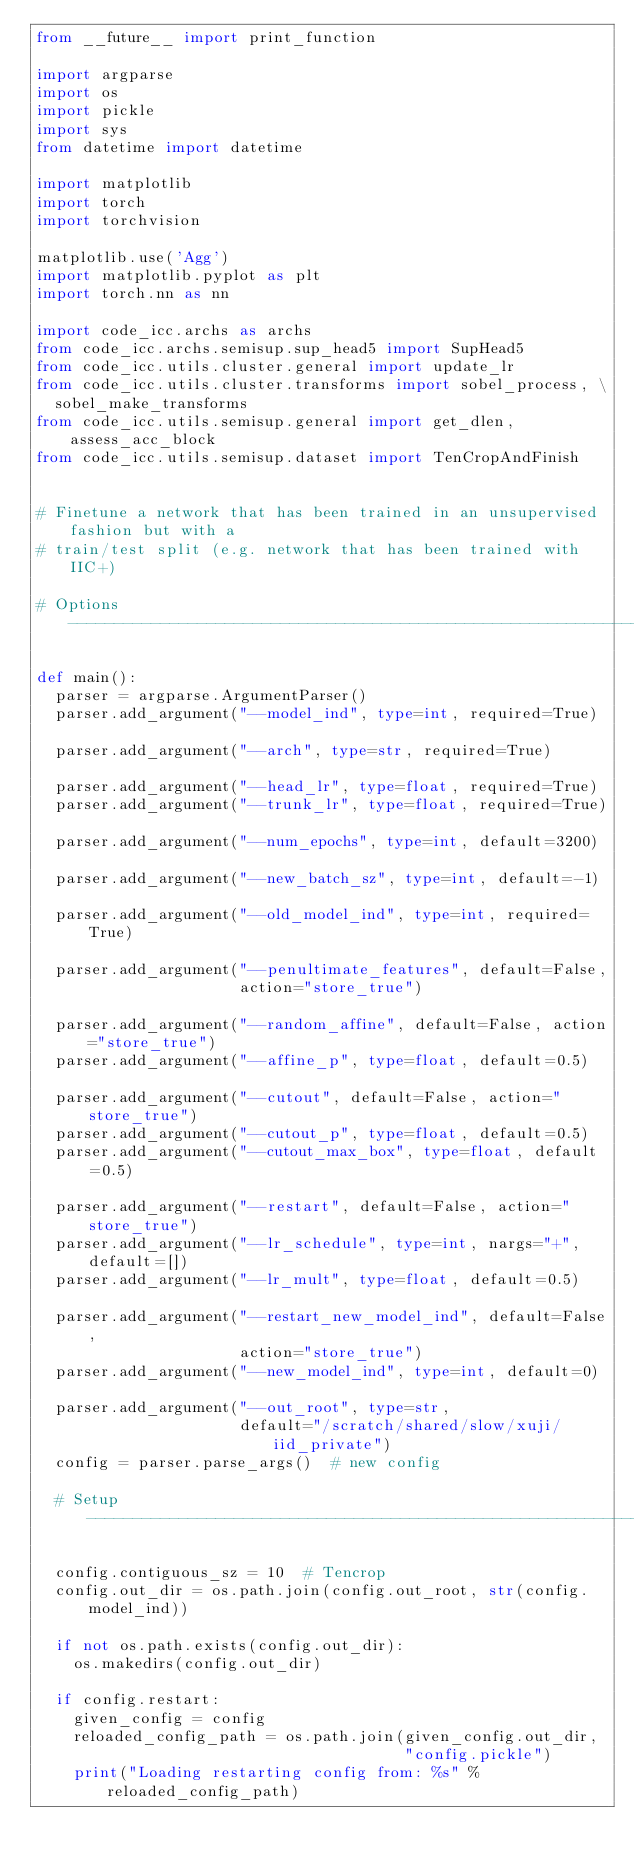<code> <loc_0><loc_0><loc_500><loc_500><_Python_>from __future__ import print_function

import argparse
import os
import pickle
import sys
from datetime import datetime

import matplotlib
import torch
import torchvision

matplotlib.use('Agg')
import matplotlib.pyplot as plt
import torch.nn as nn

import code_icc.archs as archs
from code_icc.archs.semisup.sup_head5 import SupHead5
from code_icc.utils.cluster.general import update_lr
from code_icc.utils.cluster.transforms import sobel_process, \
  sobel_make_transforms
from code_icc.utils.semisup.general import get_dlen, assess_acc_block
from code_icc.utils.semisup.dataset import TenCropAndFinish


# Finetune a network that has been trained in an unsupervised fashion but with a
# train/test split (e.g. network that has been trained with IIC+)

# Options ----------------------------------------------------------------------

def main():
  parser = argparse.ArgumentParser()
  parser.add_argument("--model_ind", type=int, required=True)

  parser.add_argument("--arch", type=str, required=True)

  parser.add_argument("--head_lr", type=float, required=True)
  parser.add_argument("--trunk_lr", type=float, required=True)

  parser.add_argument("--num_epochs", type=int, default=3200)

  parser.add_argument("--new_batch_sz", type=int, default=-1)

  parser.add_argument("--old_model_ind", type=int, required=True)

  parser.add_argument("--penultimate_features", default=False,
                      action="store_true")

  parser.add_argument("--random_affine", default=False, action="store_true")
  parser.add_argument("--affine_p", type=float, default=0.5)

  parser.add_argument("--cutout", default=False, action="store_true")
  parser.add_argument("--cutout_p", type=float, default=0.5)
  parser.add_argument("--cutout_max_box", type=float, default=0.5)

  parser.add_argument("--restart", default=False, action="store_true")
  parser.add_argument("--lr_schedule", type=int, nargs="+", default=[])
  parser.add_argument("--lr_mult", type=float, default=0.5)

  parser.add_argument("--restart_new_model_ind", default=False,
                      action="store_true")
  parser.add_argument("--new_model_ind", type=int, default=0)

  parser.add_argument("--out_root", type=str,
                      default="/scratch/shared/slow/xuji/iid_private")
  config = parser.parse_args()  # new config

  # Setup ----------------------------------------------------------------------

  config.contiguous_sz = 10  # Tencrop
  config.out_dir = os.path.join(config.out_root, str(config.model_ind))

  if not os.path.exists(config.out_dir):
    os.makedirs(config.out_dir)

  if config.restart:
    given_config = config
    reloaded_config_path = os.path.join(given_config.out_dir,
                                        "config.pickle")
    print("Loading restarting config from: %s" % reloaded_config_path)</code> 